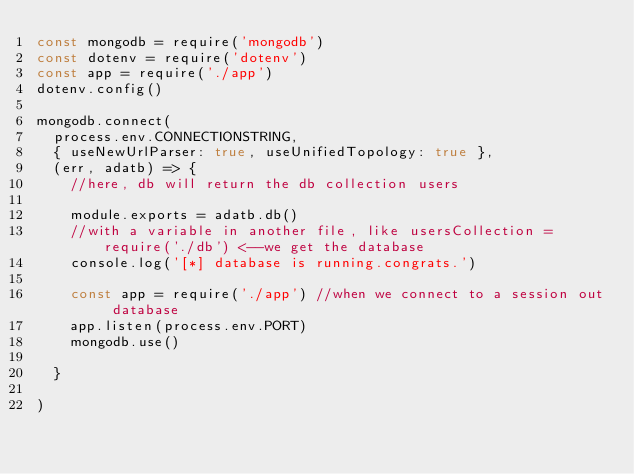<code> <loc_0><loc_0><loc_500><loc_500><_JavaScript_>const mongodb = require('mongodb')
const dotenv = require('dotenv')
const app = require('./app')
dotenv.config()

mongodb.connect(
  process.env.CONNECTIONSTRING,
  { useNewUrlParser: true, useUnifiedTopology: true },
  (err, adatb) => {
    //here, db will return the db collection users

    module.exports = adatb.db()
    //with a variable in another file, like usersCollection = require('./db') <--we get the database
    console.log('[*] database is running.congrats.')

    const app = require('./app') //when we connect to a session out database
    app.listen(process.env.PORT)
    mongodb.use()

  }
  
)

</code> 